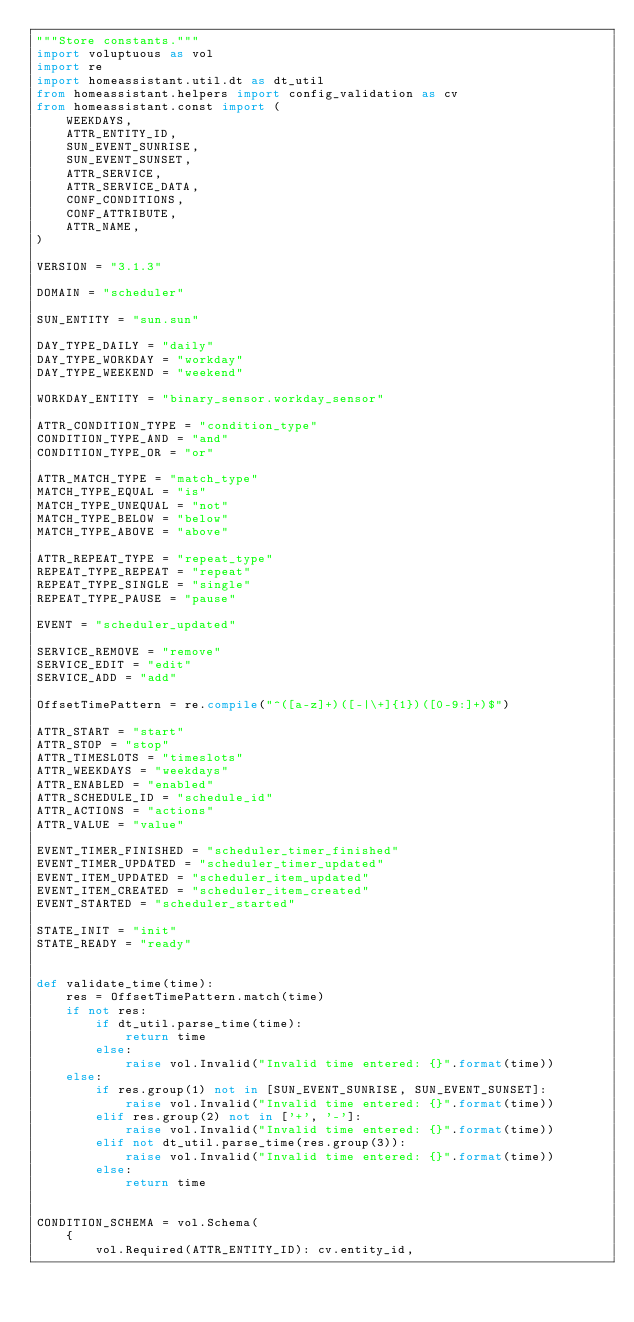<code> <loc_0><loc_0><loc_500><loc_500><_Python_>"""Store constants."""
import voluptuous as vol
import re
import homeassistant.util.dt as dt_util
from homeassistant.helpers import config_validation as cv
from homeassistant.const import (
    WEEKDAYS,
    ATTR_ENTITY_ID,
    SUN_EVENT_SUNRISE,
    SUN_EVENT_SUNSET,
    ATTR_SERVICE,
    ATTR_SERVICE_DATA,
    CONF_CONDITIONS,
    CONF_ATTRIBUTE,
    ATTR_NAME,
)

VERSION = "3.1.3"

DOMAIN = "scheduler"

SUN_ENTITY = "sun.sun"

DAY_TYPE_DAILY = "daily"
DAY_TYPE_WORKDAY = "workday"
DAY_TYPE_WEEKEND = "weekend"

WORKDAY_ENTITY = "binary_sensor.workday_sensor"

ATTR_CONDITION_TYPE = "condition_type"
CONDITION_TYPE_AND = "and"
CONDITION_TYPE_OR = "or"

ATTR_MATCH_TYPE = "match_type"
MATCH_TYPE_EQUAL = "is"
MATCH_TYPE_UNEQUAL = "not"
MATCH_TYPE_BELOW = "below"
MATCH_TYPE_ABOVE = "above"

ATTR_REPEAT_TYPE = "repeat_type"
REPEAT_TYPE_REPEAT = "repeat"
REPEAT_TYPE_SINGLE = "single"
REPEAT_TYPE_PAUSE = "pause"

EVENT = "scheduler_updated"

SERVICE_REMOVE = "remove"
SERVICE_EDIT = "edit"
SERVICE_ADD = "add"

OffsetTimePattern = re.compile("^([a-z]+)([-|\+]{1})([0-9:]+)$")

ATTR_START = "start"
ATTR_STOP = "stop"
ATTR_TIMESLOTS = "timeslots"
ATTR_WEEKDAYS = "weekdays"
ATTR_ENABLED = "enabled"
ATTR_SCHEDULE_ID = "schedule_id"
ATTR_ACTIONS = "actions"
ATTR_VALUE = "value"

EVENT_TIMER_FINISHED = "scheduler_timer_finished"
EVENT_TIMER_UPDATED = "scheduler_timer_updated"
EVENT_ITEM_UPDATED = "scheduler_item_updated"
EVENT_ITEM_CREATED = "scheduler_item_created"
EVENT_STARTED = "scheduler_started"

STATE_INIT = "init"
STATE_READY = "ready"


def validate_time(time):
    res = OffsetTimePattern.match(time)
    if not res:
        if dt_util.parse_time(time):
            return time
        else:
            raise vol.Invalid("Invalid time entered: {}".format(time))
    else:
        if res.group(1) not in [SUN_EVENT_SUNRISE, SUN_EVENT_SUNSET]:
            raise vol.Invalid("Invalid time entered: {}".format(time))
        elif res.group(2) not in ['+', '-']:
            raise vol.Invalid("Invalid time entered: {}".format(time))
        elif not dt_util.parse_time(res.group(3)):
            raise vol.Invalid("Invalid time entered: {}".format(time))
        else:
            return time


CONDITION_SCHEMA = vol.Schema(
    {
        vol.Required(ATTR_ENTITY_ID): cv.entity_id,</code> 